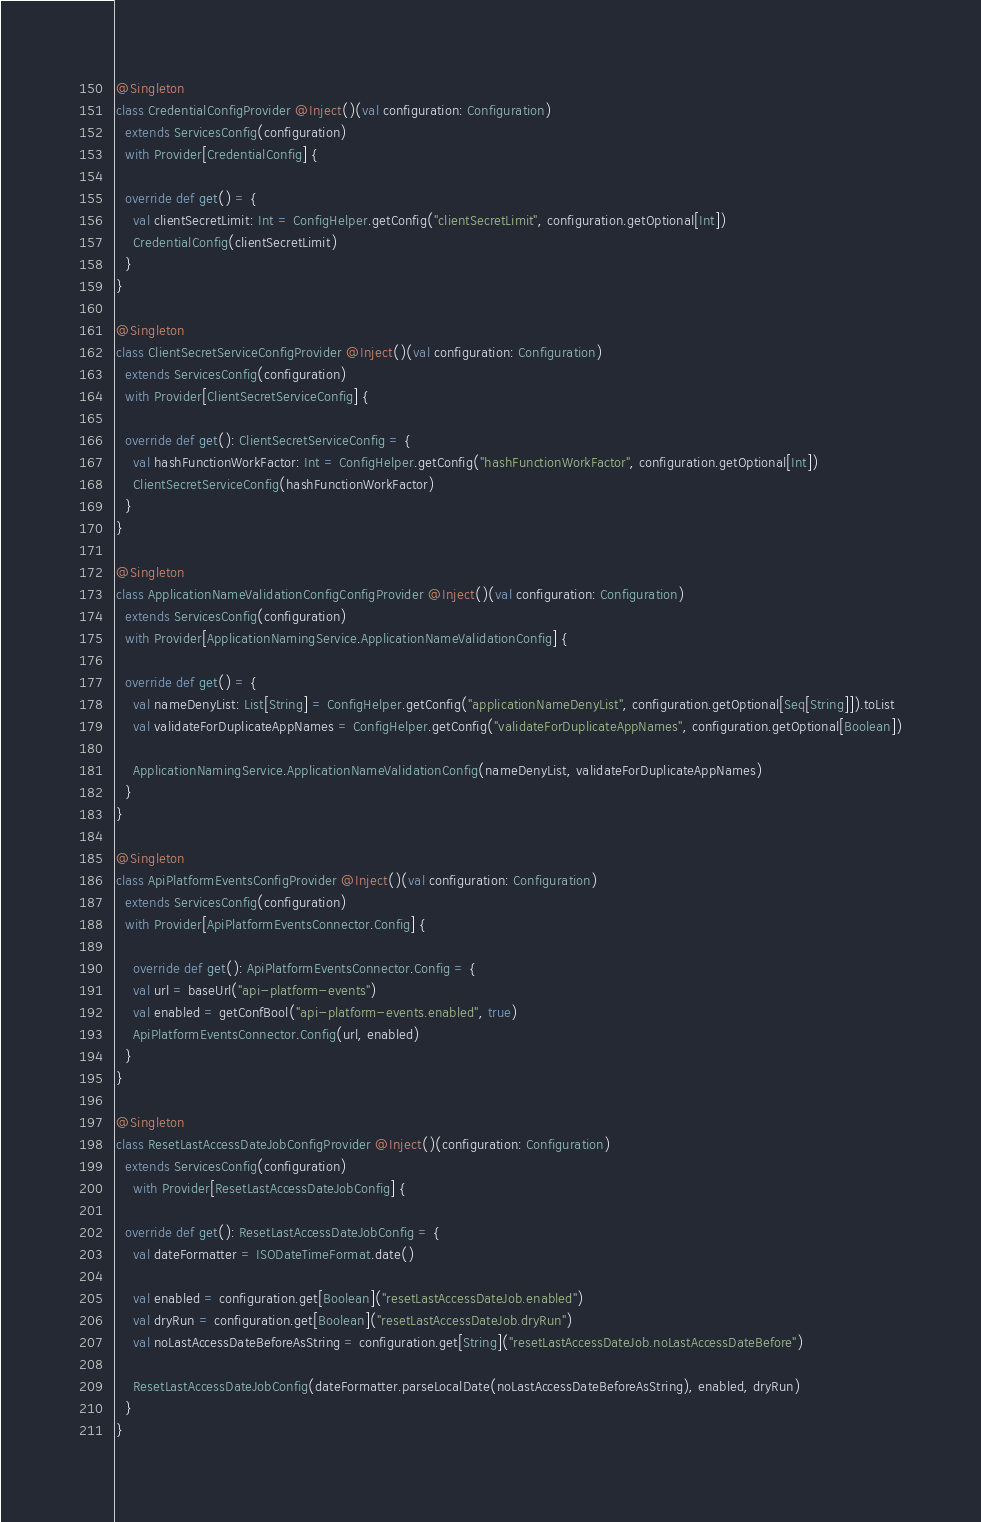<code> <loc_0><loc_0><loc_500><loc_500><_Scala_>
@Singleton
class CredentialConfigProvider @Inject()(val configuration: Configuration)
  extends ServicesConfig(configuration)
  with Provider[CredentialConfig] {

  override def get() = {
    val clientSecretLimit: Int = ConfigHelper.getConfig("clientSecretLimit", configuration.getOptional[Int])
    CredentialConfig(clientSecretLimit)
  }
}

@Singleton
class ClientSecretServiceConfigProvider @Inject()(val configuration: Configuration)
  extends ServicesConfig(configuration)
  with Provider[ClientSecretServiceConfig] {

  override def get(): ClientSecretServiceConfig = {
    val hashFunctionWorkFactor: Int = ConfigHelper.getConfig("hashFunctionWorkFactor", configuration.getOptional[Int])
    ClientSecretServiceConfig(hashFunctionWorkFactor)
  }
}

@Singleton
class ApplicationNameValidationConfigConfigProvider @Inject()(val configuration: Configuration)
  extends ServicesConfig(configuration)
  with Provider[ApplicationNamingService.ApplicationNameValidationConfig] {

  override def get() = {
    val nameDenyList: List[String] = ConfigHelper.getConfig("applicationNameDenyList", configuration.getOptional[Seq[String]]).toList
    val validateForDuplicateAppNames = ConfigHelper.getConfig("validateForDuplicateAppNames", configuration.getOptional[Boolean])

    ApplicationNamingService.ApplicationNameValidationConfig(nameDenyList, validateForDuplicateAppNames)
  }
}

@Singleton
class ApiPlatformEventsConfigProvider @Inject()(val configuration: Configuration)
  extends ServicesConfig(configuration)
  with Provider[ApiPlatformEventsConnector.Config] {

    override def get(): ApiPlatformEventsConnector.Config = {
    val url = baseUrl("api-platform-events")
    val enabled = getConfBool("api-platform-events.enabled", true)
    ApiPlatformEventsConnector.Config(url, enabled)
  }
}

@Singleton
class ResetLastAccessDateJobConfigProvider @Inject()(configuration: Configuration)
  extends ServicesConfig(configuration)
    with Provider[ResetLastAccessDateJobConfig] {

  override def get(): ResetLastAccessDateJobConfig = {
    val dateFormatter = ISODateTimeFormat.date()

    val enabled = configuration.get[Boolean]("resetLastAccessDateJob.enabled")
    val dryRun = configuration.get[Boolean]("resetLastAccessDateJob.dryRun")
    val noLastAccessDateBeforeAsString = configuration.get[String]("resetLastAccessDateJob.noLastAccessDateBefore")

    ResetLastAccessDateJobConfig(dateFormatter.parseLocalDate(noLastAccessDateBeforeAsString), enabled, dryRun)
  }
}
</code> 